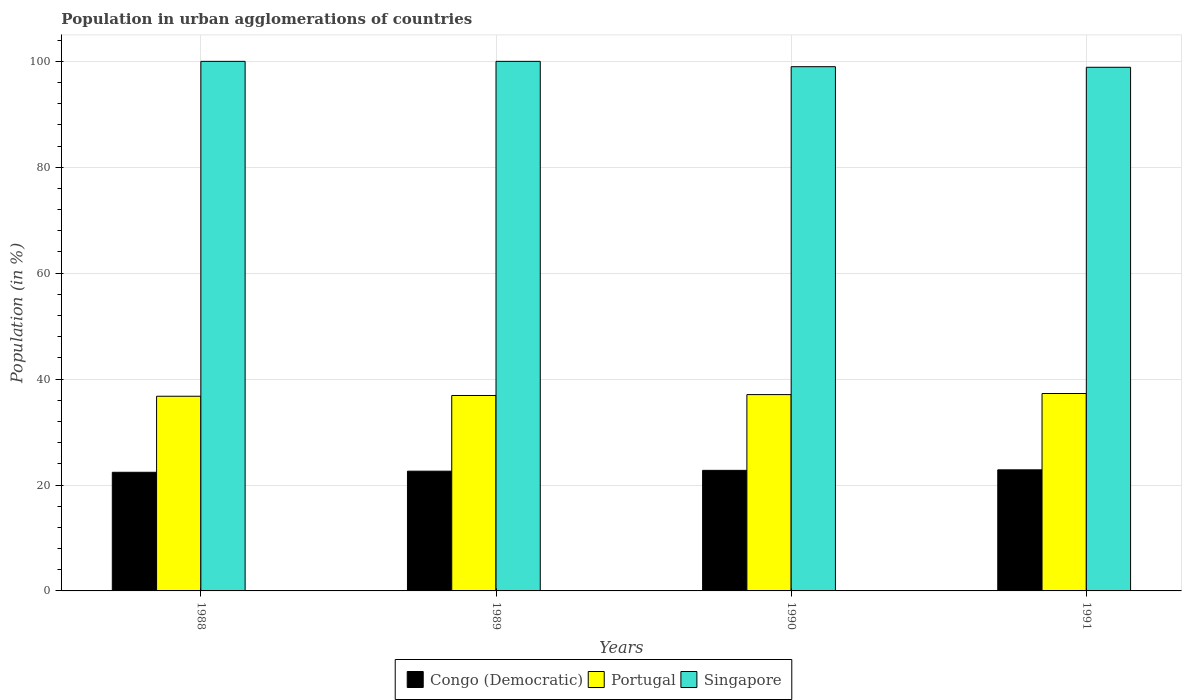How many different coloured bars are there?
Your response must be concise. 3. How many groups of bars are there?
Offer a very short reply. 4. Are the number of bars per tick equal to the number of legend labels?
Your response must be concise. Yes. How many bars are there on the 2nd tick from the left?
Make the answer very short. 3. Across all years, what is the maximum percentage of population in urban agglomerations in Portugal?
Your answer should be very brief. 37.28. Across all years, what is the minimum percentage of population in urban agglomerations in Portugal?
Your response must be concise. 36.76. In which year was the percentage of population in urban agglomerations in Portugal maximum?
Provide a short and direct response. 1991. What is the total percentage of population in urban agglomerations in Portugal in the graph?
Provide a short and direct response. 148.02. What is the difference between the percentage of population in urban agglomerations in Congo (Democratic) in 1988 and that in 1991?
Your answer should be compact. -0.46. What is the difference between the percentage of population in urban agglomerations in Portugal in 1989 and the percentage of population in urban agglomerations in Congo (Democratic) in 1990?
Keep it short and to the point. 14.14. What is the average percentage of population in urban agglomerations in Singapore per year?
Your answer should be very brief. 99.47. In the year 1989, what is the difference between the percentage of population in urban agglomerations in Singapore and percentage of population in urban agglomerations in Portugal?
Ensure brevity in your answer.  63.1. What is the ratio of the percentage of population in urban agglomerations in Portugal in 1988 to that in 1990?
Offer a very short reply. 0.99. Is the percentage of population in urban agglomerations in Singapore in 1988 less than that in 1991?
Offer a terse response. No. Is the difference between the percentage of population in urban agglomerations in Singapore in 1988 and 1991 greater than the difference between the percentage of population in urban agglomerations in Portugal in 1988 and 1991?
Provide a short and direct response. Yes. What is the difference between the highest and the lowest percentage of population in urban agglomerations in Portugal?
Your answer should be very brief. 0.52. Is the sum of the percentage of population in urban agglomerations in Singapore in 1990 and 1991 greater than the maximum percentage of population in urban agglomerations in Portugal across all years?
Your response must be concise. Yes. What does the 1st bar from the left in 1989 represents?
Your answer should be very brief. Congo (Democratic). What does the 1st bar from the right in 1991 represents?
Ensure brevity in your answer.  Singapore. How many bars are there?
Offer a very short reply. 12. What is the difference between two consecutive major ticks on the Y-axis?
Keep it short and to the point. 20. Are the values on the major ticks of Y-axis written in scientific E-notation?
Give a very brief answer. No. Does the graph contain any zero values?
Your response must be concise. No. Where does the legend appear in the graph?
Offer a very short reply. Bottom center. What is the title of the graph?
Keep it short and to the point. Population in urban agglomerations of countries. What is the Population (in %) in Congo (Democratic) in 1988?
Ensure brevity in your answer.  22.4. What is the Population (in %) of Portugal in 1988?
Offer a very short reply. 36.76. What is the Population (in %) in Congo (Democratic) in 1989?
Provide a short and direct response. 22.61. What is the Population (in %) in Portugal in 1989?
Make the answer very short. 36.9. What is the Population (in %) in Congo (Democratic) in 1990?
Keep it short and to the point. 22.77. What is the Population (in %) in Portugal in 1990?
Offer a very short reply. 37.07. What is the Population (in %) of Singapore in 1990?
Your answer should be very brief. 98.99. What is the Population (in %) in Congo (Democratic) in 1991?
Offer a very short reply. 22.87. What is the Population (in %) in Portugal in 1991?
Keep it short and to the point. 37.28. What is the Population (in %) in Singapore in 1991?
Offer a terse response. 98.88. Across all years, what is the maximum Population (in %) of Congo (Democratic)?
Your response must be concise. 22.87. Across all years, what is the maximum Population (in %) of Portugal?
Keep it short and to the point. 37.28. Across all years, what is the minimum Population (in %) in Congo (Democratic)?
Give a very brief answer. 22.4. Across all years, what is the minimum Population (in %) of Portugal?
Your answer should be compact. 36.76. Across all years, what is the minimum Population (in %) in Singapore?
Your answer should be compact. 98.88. What is the total Population (in %) of Congo (Democratic) in the graph?
Ensure brevity in your answer.  90.65. What is the total Population (in %) in Portugal in the graph?
Make the answer very short. 148.02. What is the total Population (in %) in Singapore in the graph?
Offer a terse response. 397.88. What is the difference between the Population (in %) in Congo (Democratic) in 1988 and that in 1989?
Offer a very short reply. -0.21. What is the difference between the Population (in %) of Portugal in 1988 and that in 1989?
Your answer should be very brief. -0.14. What is the difference between the Population (in %) in Congo (Democratic) in 1988 and that in 1990?
Keep it short and to the point. -0.37. What is the difference between the Population (in %) in Portugal in 1988 and that in 1990?
Your answer should be very brief. -0.31. What is the difference between the Population (in %) in Singapore in 1988 and that in 1990?
Offer a terse response. 1.01. What is the difference between the Population (in %) in Congo (Democratic) in 1988 and that in 1991?
Offer a very short reply. -0.46. What is the difference between the Population (in %) of Portugal in 1988 and that in 1991?
Offer a terse response. -0.52. What is the difference between the Population (in %) in Singapore in 1988 and that in 1991?
Offer a terse response. 1.12. What is the difference between the Population (in %) of Congo (Democratic) in 1989 and that in 1990?
Offer a terse response. -0.16. What is the difference between the Population (in %) of Portugal in 1989 and that in 1990?
Your answer should be compact. -0.17. What is the difference between the Population (in %) in Singapore in 1989 and that in 1990?
Give a very brief answer. 1.01. What is the difference between the Population (in %) in Congo (Democratic) in 1989 and that in 1991?
Make the answer very short. -0.25. What is the difference between the Population (in %) in Portugal in 1989 and that in 1991?
Your response must be concise. -0.37. What is the difference between the Population (in %) in Singapore in 1989 and that in 1991?
Ensure brevity in your answer.  1.12. What is the difference between the Population (in %) in Congo (Democratic) in 1990 and that in 1991?
Offer a terse response. -0.1. What is the difference between the Population (in %) in Portugal in 1990 and that in 1991?
Ensure brevity in your answer.  -0.2. What is the difference between the Population (in %) of Singapore in 1990 and that in 1991?
Ensure brevity in your answer.  0.11. What is the difference between the Population (in %) in Congo (Democratic) in 1988 and the Population (in %) in Portugal in 1989?
Offer a terse response. -14.5. What is the difference between the Population (in %) in Congo (Democratic) in 1988 and the Population (in %) in Singapore in 1989?
Your answer should be very brief. -77.6. What is the difference between the Population (in %) in Portugal in 1988 and the Population (in %) in Singapore in 1989?
Offer a terse response. -63.24. What is the difference between the Population (in %) of Congo (Democratic) in 1988 and the Population (in %) of Portugal in 1990?
Your answer should be very brief. -14.67. What is the difference between the Population (in %) of Congo (Democratic) in 1988 and the Population (in %) of Singapore in 1990?
Offer a terse response. -76.59. What is the difference between the Population (in %) of Portugal in 1988 and the Population (in %) of Singapore in 1990?
Your answer should be compact. -62.23. What is the difference between the Population (in %) of Congo (Democratic) in 1988 and the Population (in %) of Portugal in 1991?
Give a very brief answer. -14.88. What is the difference between the Population (in %) of Congo (Democratic) in 1988 and the Population (in %) of Singapore in 1991?
Keep it short and to the point. -76.48. What is the difference between the Population (in %) of Portugal in 1988 and the Population (in %) of Singapore in 1991?
Offer a terse response. -62.12. What is the difference between the Population (in %) in Congo (Democratic) in 1989 and the Population (in %) in Portugal in 1990?
Offer a terse response. -14.46. What is the difference between the Population (in %) in Congo (Democratic) in 1989 and the Population (in %) in Singapore in 1990?
Give a very brief answer. -76.38. What is the difference between the Population (in %) in Portugal in 1989 and the Population (in %) in Singapore in 1990?
Make the answer very short. -62.09. What is the difference between the Population (in %) in Congo (Democratic) in 1989 and the Population (in %) in Portugal in 1991?
Your answer should be very brief. -14.67. What is the difference between the Population (in %) of Congo (Democratic) in 1989 and the Population (in %) of Singapore in 1991?
Your response must be concise. -76.27. What is the difference between the Population (in %) in Portugal in 1989 and the Population (in %) in Singapore in 1991?
Provide a short and direct response. -61.98. What is the difference between the Population (in %) of Congo (Democratic) in 1990 and the Population (in %) of Portugal in 1991?
Ensure brevity in your answer.  -14.51. What is the difference between the Population (in %) in Congo (Democratic) in 1990 and the Population (in %) in Singapore in 1991?
Give a very brief answer. -76.12. What is the difference between the Population (in %) of Portugal in 1990 and the Population (in %) of Singapore in 1991?
Make the answer very short. -61.81. What is the average Population (in %) in Congo (Democratic) per year?
Provide a short and direct response. 22.66. What is the average Population (in %) in Portugal per year?
Offer a terse response. 37. What is the average Population (in %) of Singapore per year?
Offer a terse response. 99.47. In the year 1988, what is the difference between the Population (in %) of Congo (Democratic) and Population (in %) of Portugal?
Keep it short and to the point. -14.36. In the year 1988, what is the difference between the Population (in %) of Congo (Democratic) and Population (in %) of Singapore?
Offer a terse response. -77.6. In the year 1988, what is the difference between the Population (in %) of Portugal and Population (in %) of Singapore?
Offer a terse response. -63.24. In the year 1989, what is the difference between the Population (in %) of Congo (Democratic) and Population (in %) of Portugal?
Your response must be concise. -14.29. In the year 1989, what is the difference between the Population (in %) in Congo (Democratic) and Population (in %) in Singapore?
Your answer should be very brief. -77.39. In the year 1989, what is the difference between the Population (in %) of Portugal and Population (in %) of Singapore?
Keep it short and to the point. -63.1. In the year 1990, what is the difference between the Population (in %) in Congo (Democratic) and Population (in %) in Portugal?
Your answer should be very brief. -14.3. In the year 1990, what is the difference between the Population (in %) in Congo (Democratic) and Population (in %) in Singapore?
Provide a succinct answer. -76.22. In the year 1990, what is the difference between the Population (in %) of Portugal and Population (in %) of Singapore?
Your answer should be very brief. -61.92. In the year 1991, what is the difference between the Population (in %) of Congo (Democratic) and Population (in %) of Portugal?
Keep it short and to the point. -14.41. In the year 1991, what is the difference between the Population (in %) of Congo (Democratic) and Population (in %) of Singapore?
Keep it short and to the point. -76.02. In the year 1991, what is the difference between the Population (in %) of Portugal and Population (in %) of Singapore?
Give a very brief answer. -61.61. What is the ratio of the Population (in %) in Portugal in 1988 to that in 1989?
Offer a very short reply. 1. What is the ratio of the Population (in %) in Congo (Democratic) in 1988 to that in 1990?
Provide a short and direct response. 0.98. What is the ratio of the Population (in %) of Singapore in 1988 to that in 1990?
Keep it short and to the point. 1.01. What is the ratio of the Population (in %) of Congo (Democratic) in 1988 to that in 1991?
Give a very brief answer. 0.98. What is the ratio of the Population (in %) of Portugal in 1988 to that in 1991?
Keep it short and to the point. 0.99. What is the ratio of the Population (in %) of Singapore in 1988 to that in 1991?
Provide a succinct answer. 1.01. What is the ratio of the Population (in %) of Portugal in 1989 to that in 1990?
Provide a short and direct response. 1. What is the ratio of the Population (in %) in Singapore in 1989 to that in 1990?
Your answer should be compact. 1.01. What is the ratio of the Population (in %) of Congo (Democratic) in 1989 to that in 1991?
Keep it short and to the point. 0.99. What is the ratio of the Population (in %) in Portugal in 1989 to that in 1991?
Your answer should be very brief. 0.99. What is the ratio of the Population (in %) in Singapore in 1989 to that in 1991?
Your answer should be very brief. 1.01. What is the ratio of the Population (in %) in Singapore in 1990 to that in 1991?
Your answer should be very brief. 1. What is the difference between the highest and the second highest Population (in %) of Congo (Democratic)?
Offer a terse response. 0.1. What is the difference between the highest and the second highest Population (in %) of Portugal?
Give a very brief answer. 0.2. What is the difference between the highest and the second highest Population (in %) in Singapore?
Keep it short and to the point. 0. What is the difference between the highest and the lowest Population (in %) of Congo (Democratic)?
Ensure brevity in your answer.  0.46. What is the difference between the highest and the lowest Population (in %) of Portugal?
Give a very brief answer. 0.52. What is the difference between the highest and the lowest Population (in %) of Singapore?
Your response must be concise. 1.12. 